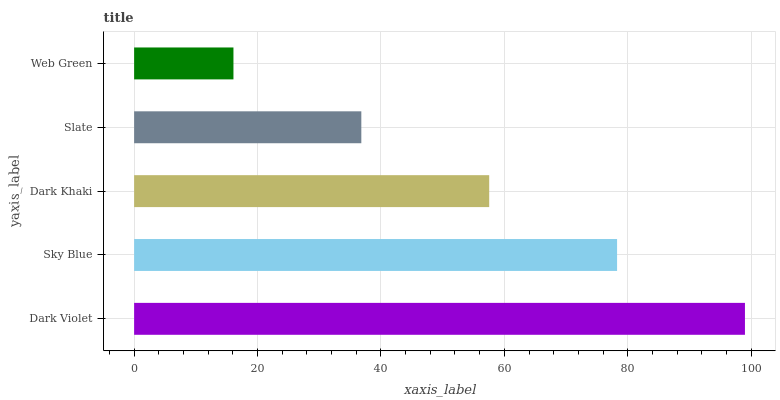Is Web Green the minimum?
Answer yes or no. Yes. Is Dark Violet the maximum?
Answer yes or no. Yes. Is Sky Blue the minimum?
Answer yes or no. No. Is Sky Blue the maximum?
Answer yes or no. No. Is Dark Violet greater than Sky Blue?
Answer yes or no. Yes. Is Sky Blue less than Dark Violet?
Answer yes or no. Yes. Is Sky Blue greater than Dark Violet?
Answer yes or no. No. Is Dark Violet less than Sky Blue?
Answer yes or no. No. Is Dark Khaki the high median?
Answer yes or no. Yes. Is Dark Khaki the low median?
Answer yes or no. Yes. Is Web Green the high median?
Answer yes or no. No. Is Web Green the low median?
Answer yes or no. No. 